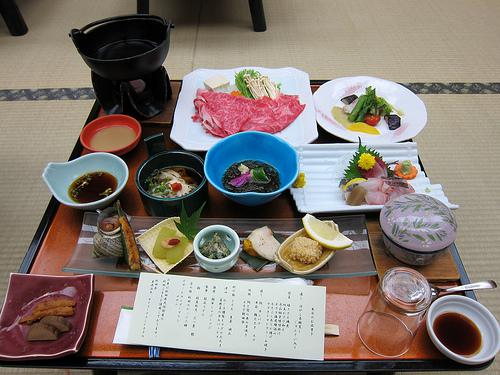Question: why is the table covered in food?
Choices:
A. Thanksgiving.
B. It's a potluck.
C. For the cookout.
D. Time to eat.
Answer with the letter. Answer: D Question: where was this photo taken?
Choices:
A. At six flags.
B. By a volcano.
C. In a restaurant.
D. At a water park.
Answer with the letter. Answer: C Question: what direction is the glass facing?
Choices:
A. Up.
B. Left.
C. Down.
D. Right.
Answer with the letter. Answer: C Question: what color is the glass?
Choices:
A. Blue.
B. Green.
C. Clear.
D. Grey.
Answer with the letter. Answer: C 